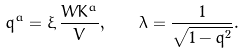Convert formula to latex. <formula><loc_0><loc_0><loc_500><loc_500>q ^ { a } = \xi \, { \frac { W K ^ { a } } { V } } , \quad \lambda = { \frac { 1 } { \sqrt { 1 - q ^ { 2 } } } } .</formula> 